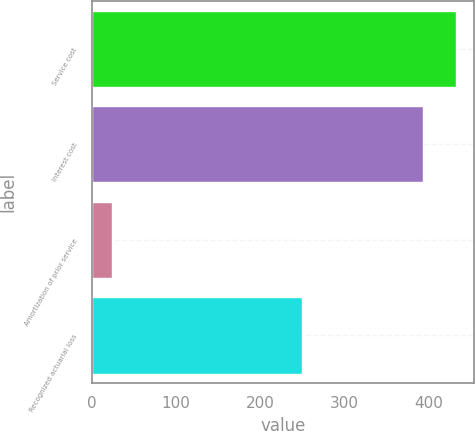Convert chart to OTSL. <chart><loc_0><loc_0><loc_500><loc_500><bar_chart><fcel>Service cost<fcel>Interest cost<fcel>Amortization of prior service<fcel>Recognized actuarial loss<nl><fcel>431.7<fcel>393<fcel>24<fcel>249<nl></chart> 